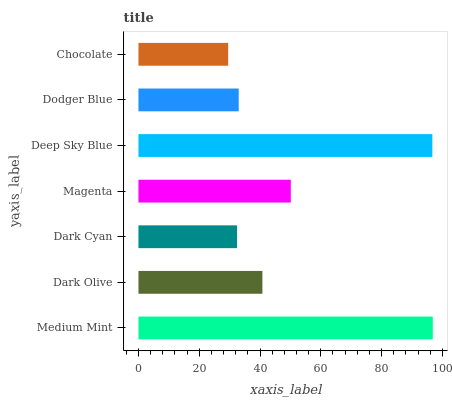Is Chocolate the minimum?
Answer yes or no. Yes. Is Medium Mint the maximum?
Answer yes or no. Yes. Is Dark Olive the minimum?
Answer yes or no. No. Is Dark Olive the maximum?
Answer yes or no. No. Is Medium Mint greater than Dark Olive?
Answer yes or no. Yes. Is Dark Olive less than Medium Mint?
Answer yes or no. Yes. Is Dark Olive greater than Medium Mint?
Answer yes or no. No. Is Medium Mint less than Dark Olive?
Answer yes or no. No. Is Dark Olive the high median?
Answer yes or no. Yes. Is Dark Olive the low median?
Answer yes or no. Yes. Is Dodger Blue the high median?
Answer yes or no. No. Is Dodger Blue the low median?
Answer yes or no. No. 